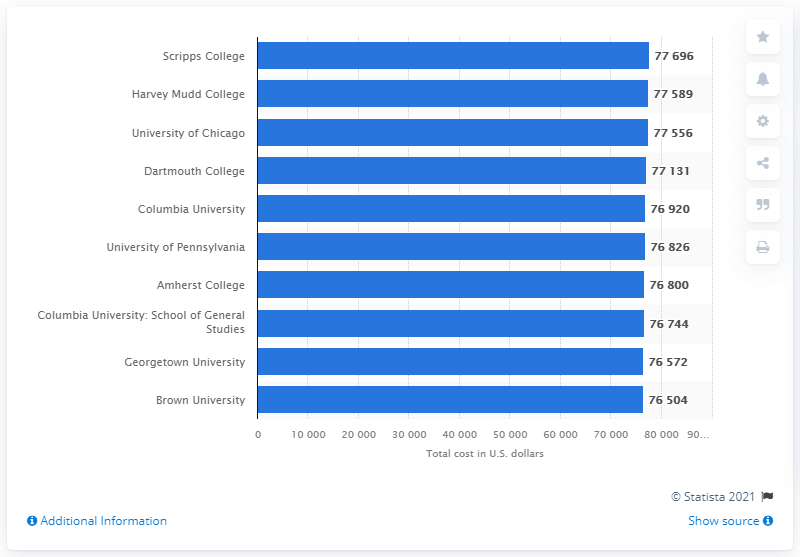Identify some key points in this picture. In 2020-2021, Scripps College was the most expensive college in the United States. 